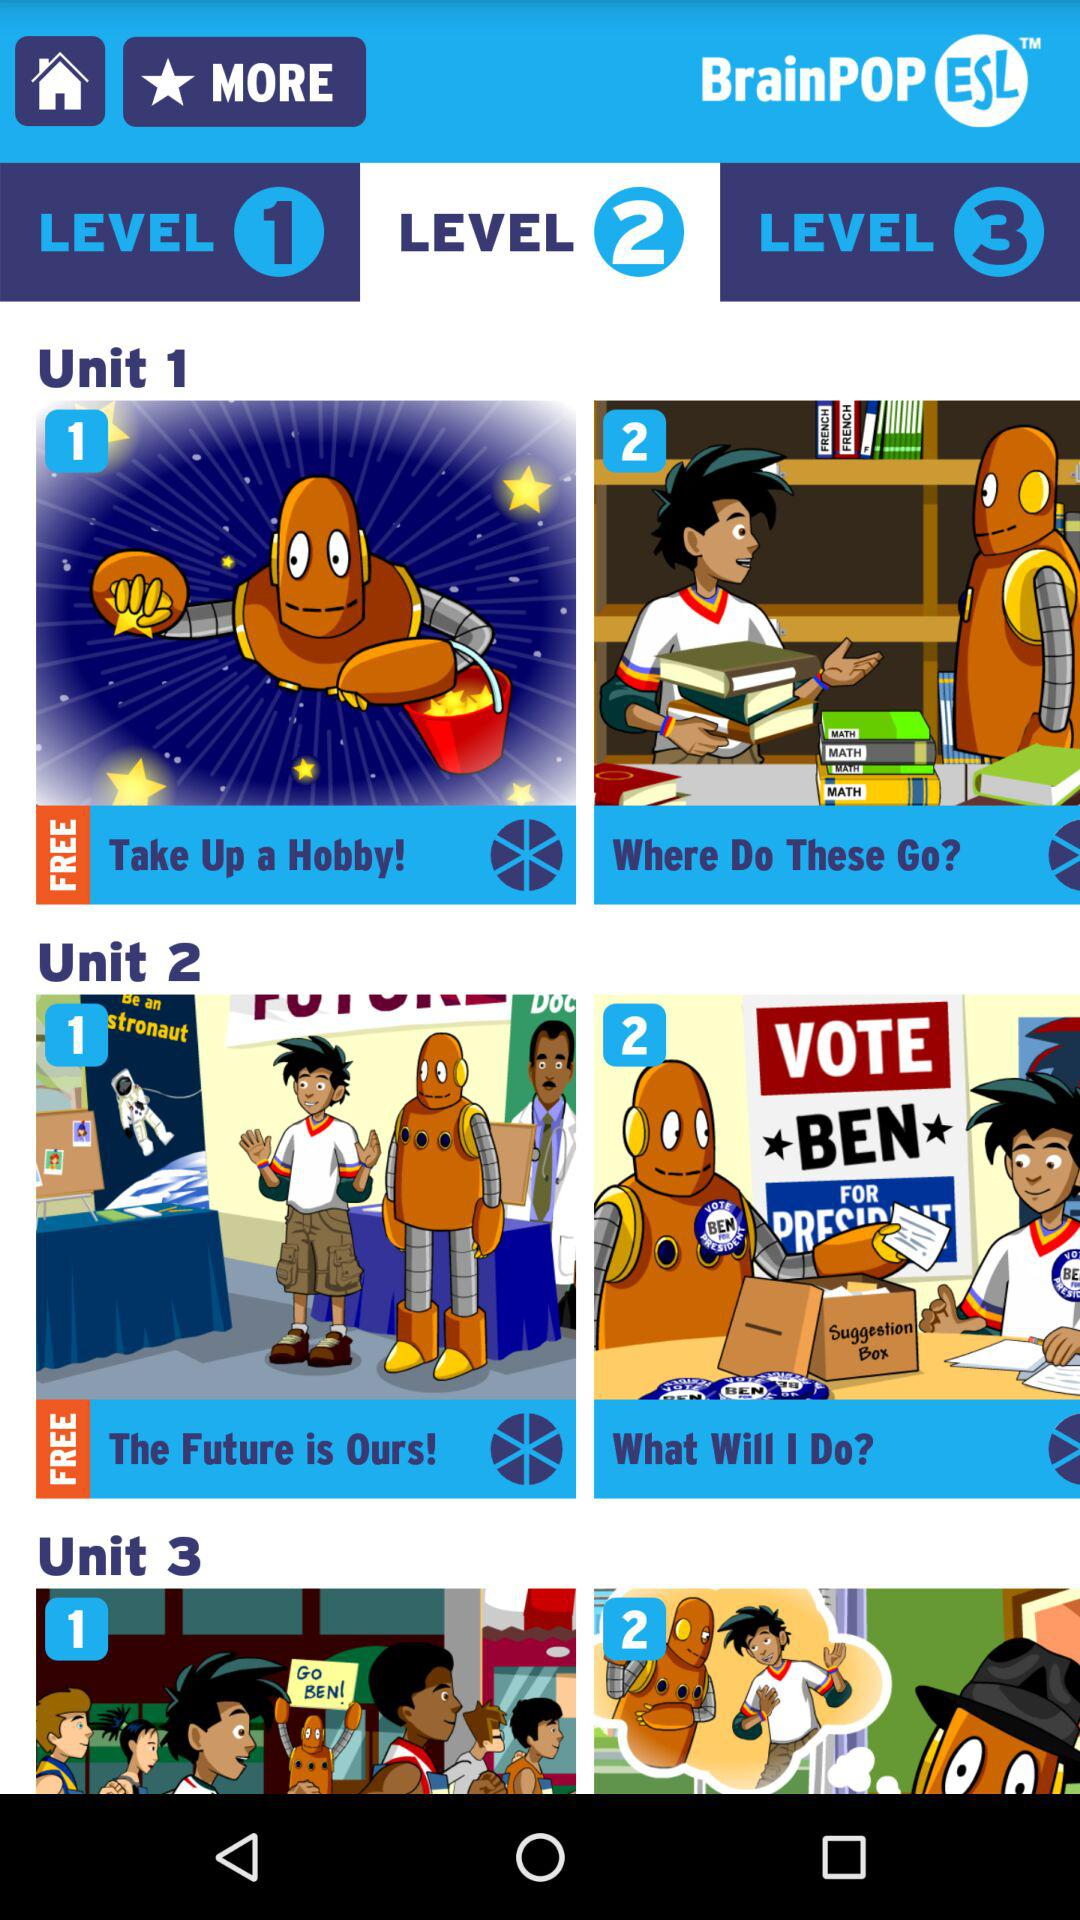What is the name of the application? The name of the application is "BrainPOP ESL". 